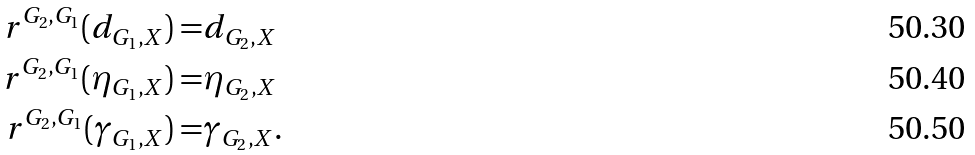<formula> <loc_0><loc_0><loc_500><loc_500>r ^ { G _ { 2 } , G _ { 1 } } ( d _ { G _ { 1 } , X } ) = & d _ { G _ { 2 } , X } \\ r ^ { G _ { 2 } , G _ { 1 } } ( \eta _ { G _ { 1 } , X } ) = & \eta _ { G _ { 2 } , X } \\ r ^ { G _ { 2 } , G _ { 1 } } ( \gamma _ { G _ { 1 } , X } ) = & \gamma _ { G _ { 2 } , X } .</formula> 